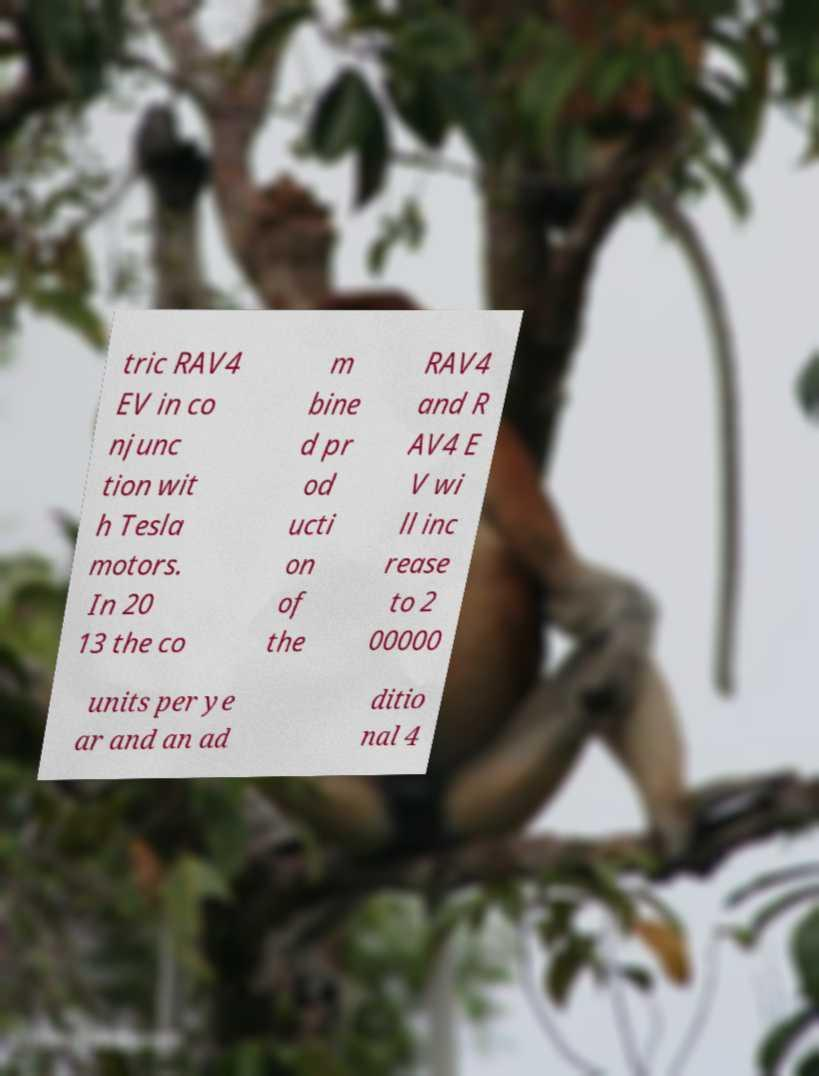There's text embedded in this image that I need extracted. Can you transcribe it verbatim? tric RAV4 EV in co njunc tion wit h Tesla motors. In 20 13 the co m bine d pr od ucti on of the RAV4 and R AV4 E V wi ll inc rease to 2 00000 units per ye ar and an ad ditio nal 4 